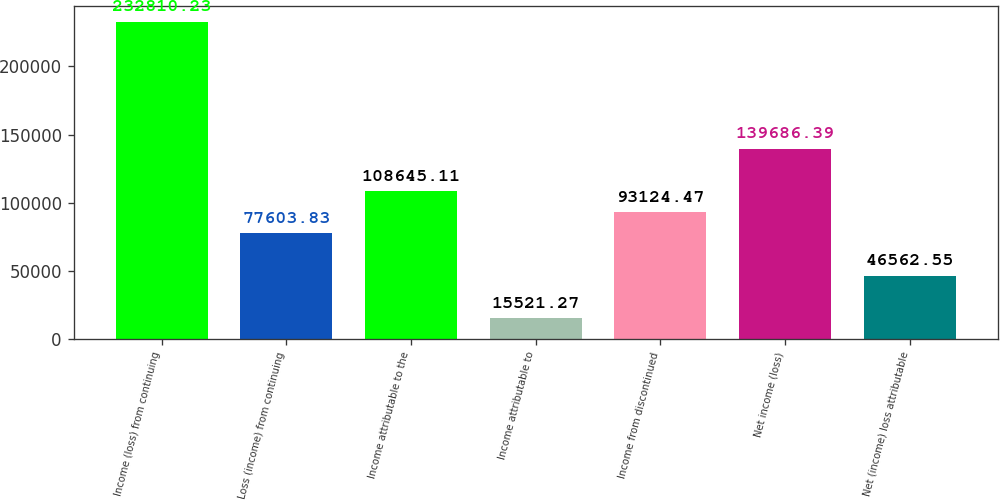Convert chart. <chart><loc_0><loc_0><loc_500><loc_500><bar_chart><fcel>Income (loss) from continuing<fcel>Loss (income) from continuing<fcel>Income attributable to the<fcel>Income attributable to<fcel>Income from discontinued<fcel>Net income (loss)<fcel>Net (income) loss attributable<nl><fcel>232810<fcel>77603.8<fcel>108645<fcel>15521.3<fcel>93124.5<fcel>139686<fcel>46562.6<nl></chart> 